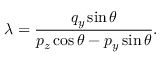<formula> <loc_0><loc_0><loc_500><loc_500>\lambda = \frac { q _ { y } \sin \theta } { p _ { z } \cos \theta - p _ { y } \sin \theta } .</formula> 